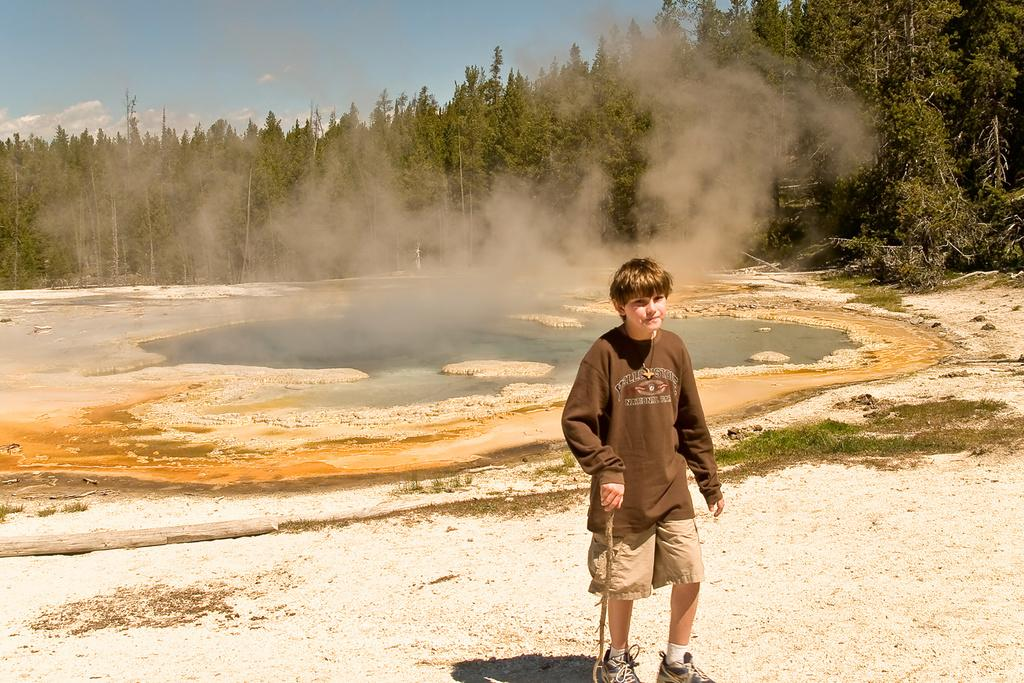What is the main subject of the image? There is a boy standing on the land in the image. What is located behind the land in the image? There is a water surface behind the land. What is an unusual feature of the water in the image? The water is emitting smoke. What type of vegetation can be seen in the background of the image? There are trees in the background of the image. What type of chess piece is floating on the water in the image? There is no chess piece present in the image. Can you describe the crow's behavior in the image? There is no crow present in the image. 